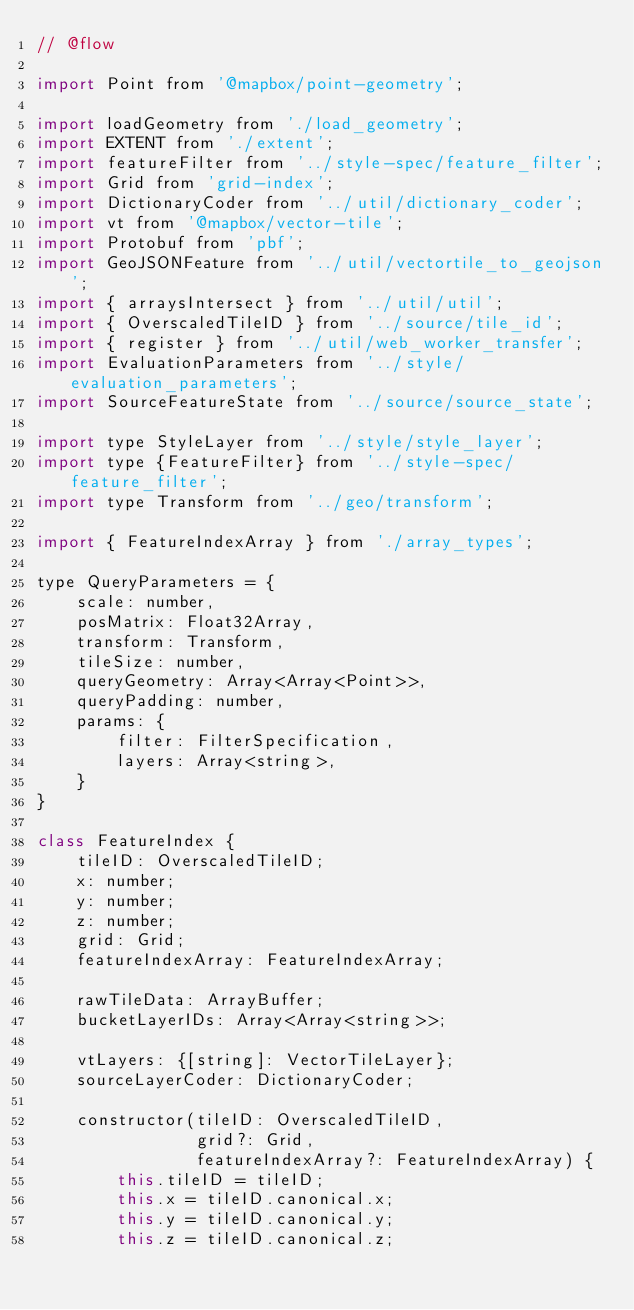Convert code to text. <code><loc_0><loc_0><loc_500><loc_500><_JavaScript_>// @flow

import Point from '@mapbox/point-geometry';

import loadGeometry from './load_geometry';
import EXTENT from './extent';
import featureFilter from '../style-spec/feature_filter';
import Grid from 'grid-index';
import DictionaryCoder from '../util/dictionary_coder';
import vt from '@mapbox/vector-tile';
import Protobuf from 'pbf';
import GeoJSONFeature from '../util/vectortile_to_geojson';
import { arraysIntersect } from '../util/util';
import { OverscaledTileID } from '../source/tile_id';
import { register } from '../util/web_worker_transfer';
import EvaluationParameters from '../style/evaluation_parameters';
import SourceFeatureState from '../source/source_state';

import type StyleLayer from '../style/style_layer';
import type {FeatureFilter} from '../style-spec/feature_filter';
import type Transform from '../geo/transform';

import { FeatureIndexArray } from './array_types';

type QueryParameters = {
    scale: number,
    posMatrix: Float32Array,
    transform: Transform,
    tileSize: number,
    queryGeometry: Array<Array<Point>>,
    queryPadding: number,
    params: {
        filter: FilterSpecification,
        layers: Array<string>,
    }
}

class FeatureIndex {
    tileID: OverscaledTileID;
    x: number;
    y: number;
    z: number;
    grid: Grid;
    featureIndexArray: FeatureIndexArray;

    rawTileData: ArrayBuffer;
    bucketLayerIDs: Array<Array<string>>;

    vtLayers: {[string]: VectorTileLayer};
    sourceLayerCoder: DictionaryCoder;

    constructor(tileID: OverscaledTileID,
                grid?: Grid,
                featureIndexArray?: FeatureIndexArray) {
        this.tileID = tileID;
        this.x = tileID.canonical.x;
        this.y = tileID.canonical.y;
        this.z = tileID.canonical.z;</code> 